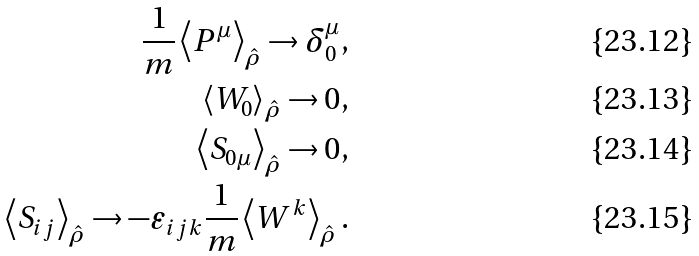<formula> <loc_0><loc_0><loc_500><loc_500>\frac { 1 } { m } \left < P ^ { \mu } \right > _ { \hat { \rho } } \to \delta ^ { \mu } _ { 0 } , \\ \left < W _ { 0 } \right > _ { \hat { \rho } } \to 0 , \\ \left < S _ { 0 \mu } \right > _ { \hat { \rho } } \to 0 , \\ \left < S _ { i j } \right > _ { \hat { \rho } } \to - \varepsilon _ { i j k } \frac { 1 } { m } \left < W ^ { k } \right > _ { \hat { \rho } } .</formula> 